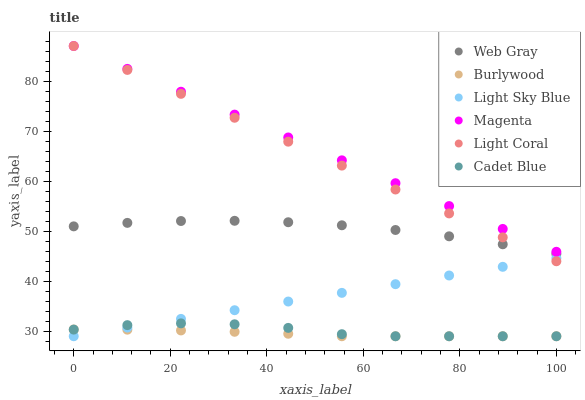Does Burlywood have the minimum area under the curve?
Answer yes or no. Yes. Does Magenta have the maximum area under the curve?
Answer yes or no. Yes. Does Light Coral have the minimum area under the curve?
Answer yes or no. No. Does Light Coral have the maximum area under the curve?
Answer yes or no. No. Is Light Coral the smoothest?
Answer yes or no. Yes. Is Cadet Blue the roughest?
Answer yes or no. Yes. Is Burlywood the smoothest?
Answer yes or no. No. Is Burlywood the roughest?
Answer yes or no. No. Does Burlywood have the lowest value?
Answer yes or no. Yes. Does Light Coral have the lowest value?
Answer yes or no. No. Does Magenta have the highest value?
Answer yes or no. Yes. Does Burlywood have the highest value?
Answer yes or no. No. Is Cadet Blue less than Light Coral?
Answer yes or no. Yes. Is Magenta greater than Cadet Blue?
Answer yes or no. Yes. Does Light Sky Blue intersect Cadet Blue?
Answer yes or no. Yes. Is Light Sky Blue less than Cadet Blue?
Answer yes or no. No. Is Light Sky Blue greater than Cadet Blue?
Answer yes or no. No. Does Cadet Blue intersect Light Coral?
Answer yes or no. No. 